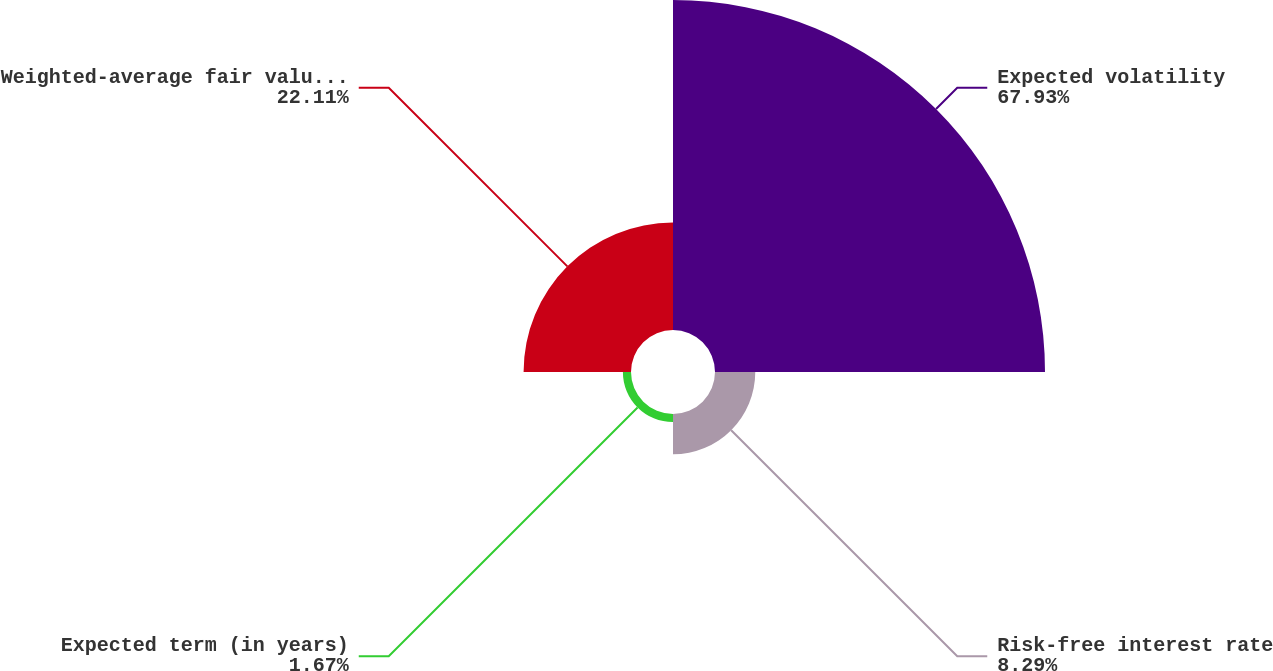Convert chart. <chart><loc_0><loc_0><loc_500><loc_500><pie_chart><fcel>Expected volatility<fcel>Risk-free interest rate<fcel>Expected term (in years)<fcel>Weighted-average fair value of<nl><fcel>67.93%<fcel>8.29%<fcel>1.67%<fcel>22.11%<nl></chart> 